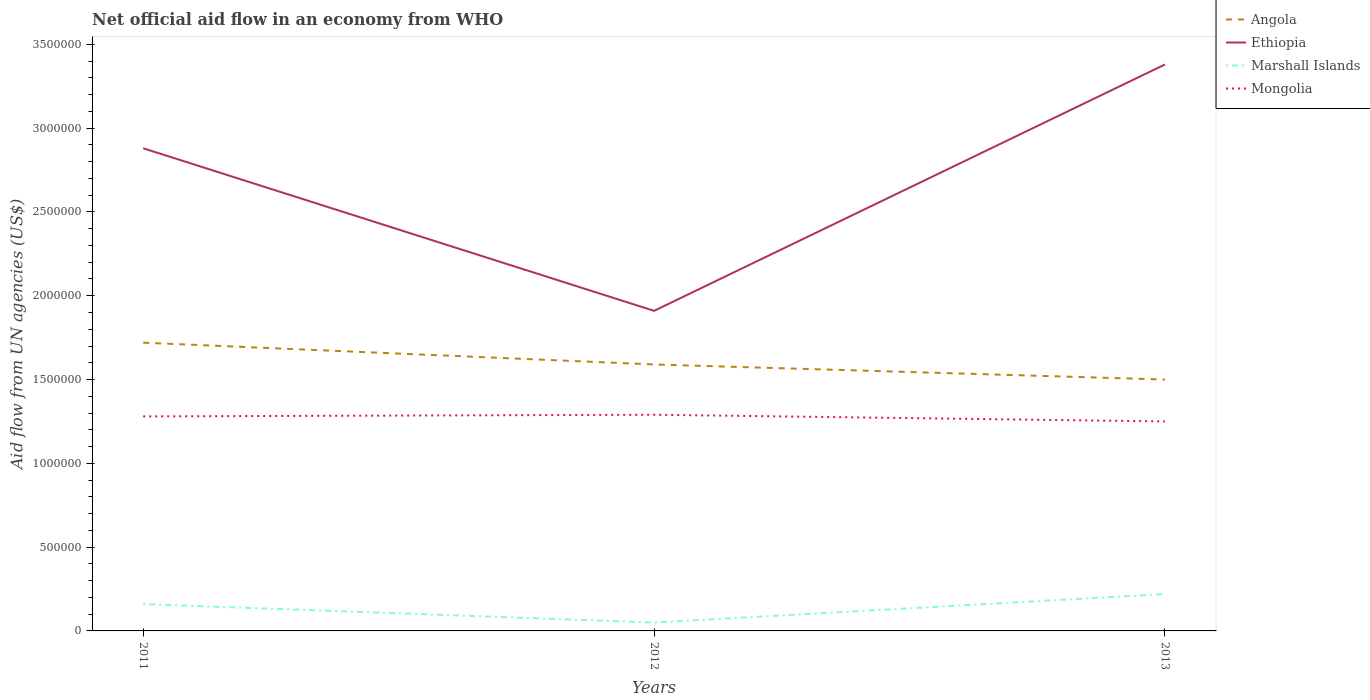Across all years, what is the maximum net official aid flow in Angola?
Provide a short and direct response. 1.50e+06. What is the total net official aid flow in Ethiopia in the graph?
Give a very brief answer. -5.00e+05. What is the difference between the highest and the second highest net official aid flow in Ethiopia?
Provide a succinct answer. 1.47e+06. How many lines are there?
Offer a very short reply. 4. Does the graph contain grids?
Provide a succinct answer. No. Where does the legend appear in the graph?
Keep it short and to the point. Top right. How are the legend labels stacked?
Keep it short and to the point. Vertical. What is the title of the graph?
Offer a terse response. Net official aid flow in an economy from WHO. What is the label or title of the Y-axis?
Offer a very short reply. Aid flow from UN agencies (US$). What is the Aid flow from UN agencies (US$) in Angola in 2011?
Your answer should be very brief. 1.72e+06. What is the Aid flow from UN agencies (US$) of Ethiopia in 2011?
Keep it short and to the point. 2.88e+06. What is the Aid flow from UN agencies (US$) in Marshall Islands in 2011?
Keep it short and to the point. 1.60e+05. What is the Aid flow from UN agencies (US$) in Mongolia in 2011?
Offer a very short reply. 1.28e+06. What is the Aid flow from UN agencies (US$) of Angola in 2012?
Keep it short and to the point. 1.59e+06. What is the Aid flow from UN agencies (US$) in Ethiopia in 2012?
Give a very brief answer. 1.91e+06. What is the Aid flow from UN agencies (US$) in Marshall Islands in 2012?
Provide a succinct answer. 5.00e+04. What is the Aid flow from UN agencies (US$) in Mongolia in 2012?
Your response must be concise. 1.29e+06. What is the Aid flow from UN agencies (US$) in Angola in 2013?
Offer a terse response. 1.50e+06. What is the Aid flow from UN agencies (US$) of Ethiopia in 2013?
Your response must be concise. 3.38e+06. What is the Aid flow from UN agencies (US$) in Marshall Islands in 2013?
Provide a succinct answer. 2.20e+05. What is the Aid flow from UN agencies (US$) in Mongolia in 2013?
Keep it short and to the point. 1.25e+06. Across all years, what is the maximum Aid flow from UN agencies (US$) of Angola?
Offer a terse response. 1.72e+06. Across all years, what is the maximum Aid flow from UN agencies (US$) of Ethiopia?
Give a very brief answer. 3.38e+06. Across all years, what is the maximum Aid flow from UN agencies (US$) of Mongolia?
Offer a very short reply. 1.29e+06. Across all years, what is the minimum Aid flow from UN agencies (US$) in Angola?
Provide a succinct answer. 1.50e+06. Across all years, what is the minimum Aid flow from UN agencies (US$) in Ethiopia?
Offer a terse response. 1.91e+06. Across all years, what is the minimum Aid flow from UN agencies (US$) in Mongolia?
Keep it short and to the point. 1.25e+06. What is the total Aid flow from UN agencies (US$) of Angola in the graph?
Your answer should be compact. 4.81e+06. What is the total Aid flow from UN agencies (US$) in Ethiopia in the graph?
Offer a terse response. 8.17e+06. What is the total Aid flow from UN agencies (US$) in Marshall Islands in the graph?
Your response must be concise. 4.30e+05. What is the total Aid flow from UN agencies (US$) in Mongolia in the graph?
Give a very brief answer. 3.82e+06. What is the difference between the Aid flow from UN agencies (US$) of Ethiopia in 2011 and that in 2012?
Give a very brief answer. 9.70e+05. What is the difference between the Aid flow from UN agencies (US$) of Angola in 2011 and that in 2013?
Keep it short and to the point. 2.20e+05. What is the difference between the Aid flow from UN agencies (US$) of Ethiopia in 2011 and that in 2013?
Your response must be concise. -5.00e+05. What is the difference between the Aid flow from UN agencies (US$) of Marshall Islands in 2011 and that in 2013?
Offer a very short reply. -6.00e+04. What is the difference between the Aid flow from UN agencies (US$) of Angola in 2012 and that in 2013?
Provide a succinct answer. 9.00e+04. What is the difference between the Aid flow from UN agencies (US$) in Ethiopia in 2012 and that in 2013?
Keep it short and to the point. -1.47e+06. What is the difference between the Aid flow from UN agencies (US$) in Marshall Islands in 2012 and that in 2013?
Give a very brief answer. -1.70e+05. What is the difference between the Aid flow from UN agencies (US$) in Angola in 2011 and the Aid flow from UN agencies (US$) in Ethiopia in 2012?
Provide a succinct answer. -1.90e+05. What is the difference between the Aid flow from UN agencies (US$) of Angola in 2011 and the Aid flow from UN agencies (US$) of Marshall Islands in 2012?
Offer a terse response. 1.67e+06. What is the difference between the Aid flow from UN agencies (US$) in Angola in 2011 and the Aid flow from UN agencies (US$) in Mongolia in 2012?
Provide a short and direct response. 4.30e+05. What is the difference between the Aid flow from UN agencies (US$) of Ethiopia in 2011 and the Aid flow from UN agencies (US$) of Marshall Islands in 2012?
Provide a short and direct response. 2.83e+06. What is the difference between the Aid flow from UN agencies (US$) of Ethiopia in 2011 and the Aid flow from UN agencies (US$) of Mongolia in 2012?
Give a very brief answer. 1.59e+06. What is the difference between the Aid flow from UN agencies (US$) of Marshall Islands in 2011 and the Aid flow from UN agencies (US$) of Mongolia in 2012?
Make the answer very short. -1.13e+06. What is the difference between the Aid flow from UN agencies (US$) of Angola in 2011 and the Aid flow from UN agencies (US$) of Ethiopia in 2013?
Ensure brevity in your answer.  -1.66e+06. What is the difference between the Aid flow from UN agencies (US$) in Angola in 2011 and the Aid flow from UN agencies (US$) in Marshall Islands in 2013?
Offer a very short reply. 1.50e+06. What is the difference between the Aid flow from UN agencies (US$) in Ethiopia in 2011 and the Aid flow from UN agencies (US$) in Marshall Islands in 2013?
Give a very brief answer. 2.66e+06. What is the difference between the Aid flow from UN agencies (US$) in Ethiopia in 2011 and the Aid flow from UN agencies (US$) in Mongolia in 2013?
Make the answer very short. 1.63e+06. What is the difference between the Aid flow from UN agencies (US$) in Marshall Islands in 2011 and the Aid flow from UN agencies (US$) in Mongolia in 2013?
Keep it short and to the point. -1.09e+06. What is the difference between the Aid flow from UN agencies (US$) of Angola in 2012 and the Aid flow from UN agencies (US$) of Ethiopia in 2013?
Provide a succinct answer. -1.79e+06. What is the difference between the Aid flow from UN agencies (US$) in Angola in 2012 and the Aid flow from UN agencies (US$) in Marshall Islands in 2013?
Give a very brief answer. 1.37e+06. What is the difference between the Aid flow from UN agencies (US$) of Ethiopia in 2012 and the Aid flow from UN agencies (US$) of Marshall Islands in 2013?
Ensure brevity in your answer.  1.69e+06. What is the difference between the Aid flow from UN agencies (US$) of Marshall Islands in 2012 and the Aid flow from UN agencies (US$) of Mongolia in 2013?
Provide a succinct answer. -1.20e+06. What is the average Aid flow from UN agencies (US$) of Angola per year?
Offer a terse response. 1.60e+06. What is the average Aid flow from UN agencies (US$) of Ethiopia per year?
Your response must be concise. 2.72e+06. What is the average Aid flow from UN agencies (US$) of Marshall Islands per year?
Your answer should be compact. 1.43e+05. What is the average Aid flow from UN agencies (US$) of Mongolia per year?
Provide a succinct answer. 1.27e+06. In the year 2011, what is the difference between the Aid flow from UN agencies (US$) of Angola and Aid flow from UN agencies (US$) of Ethiopia?
Provide a short and direct response. -1.16e+06. In the year 2011, what is the difference between the Aid flow from UN agencies (US$) in Angola and Aid flow from UN agencies (US$) in Marshall Islands?
Keep it short and to the point. 1.56e+06. In the year 2011, what is the difference between the Aid flow from UN agencies (US$) of Ethiopia and Aid flow from UN agencies (US$) of Marshall Islands?
Ensure brevity in your answer.  2.72e+06. In the year 2011, what is the difference between the Aid flow from UN agencies (US$) in Ethiopia and Aid flow from UN agencies (US$) in Mongolia?
Provide a short and direct response. 1.60e+06. In the year 2011, what is the difference between the Aid flow from UN agencies (US$) in Marshall Islands and Aid flow from UN agencies (US$) in Mongolia?
Provide a succinct answer. -1.12e+06. In the year 2012, what is the difference between the Aid flow from UN agencies (US$) of Angola and Aid flow from UN agencies (US$) of Ethiopia?
Your response must be concise. -3.20e+05. In the year 2012, what is the difference between the Aid flow from UN agencies (US$) in Angola and Aid flow from UN agencies (US$) in Marshall Islands?
Give a very brief answer. 1.54e+06. In the year 2012, what is the difference between the Aid flow from UN agencies (US$) in Angola and Aid flow from UN agencies (US$) in Mongolia?
Make the answer very short. 3.00e+05. In the year 2012, what is the difference between the Aid flow from UN agencies (US$) in Ethiopia and Aid flow from UN agencies (US$) in Marshall Islands?
Provide a short and direct response. 1.86e+06. In the year 2012, what is the difference between the Aid flow from UN agencies (US$) of Ethiopia and Aid flow from UN agencies (US$) of Mongolia?
Keep it short and to the point. 6.20e+05. In the year 2012, what is the difference between the Aid flow from UN agencies (US$) in Marshall Islands and Aid flow from UN agencies (US$) in Mongolia?
Keep it short and to the point. -1.24e+06. In the year 2013, what is the difference between the Aid flow from UN agencies (US$) of Angola and Aid flow from UN agencies (US$) of Ethiopia?
Offer a very short reply. -1.88e+06. In the year 2013, what is the difference between the Aid flow from UN agencies (US$) of Angola and Aid flow from UN agencies (US$) of Marshall Islands?
Make the answer very short. 1.28e+06. In the year 2013, what is the difference between the Aid flow from UN agencies (US$) of Ethiopia and Aid flow from UN agencies (US$) of Marshall Islands?
Make the answer very short. 3.16e+06. In the year 2013, what is the difference between the Aid flow from UN agencies (US$) in Ethiopia and Aid flow from UN agencies (US$) in Mongolia?
Provide a short and direct response. 2.13e+06. In the year 2013, what is the difference between the Aid flow from UN agencies (US$) in Marshall Islands and Aid flow from UN agencies (US$) in Mongolia?
Give a very brief answer. -1.03e+06. What is the ratio of the Aid flow from UN agencies (US$) of Angola in 2011 to that in 2012?
Provide a short and direct response. 1.08. What is the ratio of the Aid flow from UN agencies (US$) in Ethiopia in 2011 to that in 2012?
Keep it short and to the point. 1.51. What is the ratio of the Aid flow from UN agencies (US$) in Angola in 2011 to that in 2013?
Make the answer very short. 1.15. What is the ratio of the Aid flow from UN agencies (US$) of Ethiopia in 2011 to that in 2013?
Provide a succinct answer. 0.85. What is the ratio of the Aid flow from UN agencies (US$) of Marshall Islands in 2011 to that in 2013?
Your answer should be very brief. 0.73. What is the ratio of the Aid flow from UN agencies (US$) in Angola in 2012 to that in 2013?
Make the answer very short. 1.06. What is the ratio of the Aid flow from UN agencies (US$) in Ethiopia in 2012 to that in 2013?
Ensure brevity in your answer.  0.57. What is the ratio of the Aid flow from UN agencies (US$) of Marshall Islands in 2012 to that in 2013?
Offer a very short reply. 0.23. What is the ratio of the Aid flow from UN agencies (US$) in Mongolia in 2012 to that in 2013?
Ensure brevity in your answer.  1.03. What is the difference between the highest and the second highest Aid flow from UN agencies (US$) of Angola?
Ensure brevity in your answer.  1.30e+05. What is the difference between the highest and the lowest Aid flow from UN agencies (US$) in Ethiopia?
Your answer should be very brief. 1.47e+06. What is the difference between the highest and the lowest Aid flow from UN agencies (US$) in Marshall Islands?
Offer a very short reply. 1.70e+05. What is the difference between the highest and the lowest Aid flow from UN agencies (US$) in Mongolia?
Provide a short and direct response. 4.00e+04. 